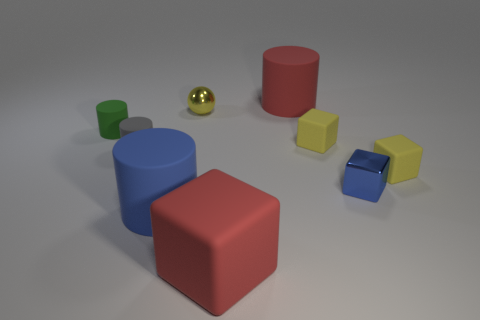Add 1 tiny matte cylinders. How many objects exist? 10 Subtract all blocks. How many objects are left? 5 Add 8 large cylinders. How many large cylinders exist? 10 Subtract 0 brown balls. How many objects are left? 9 Subtract all tiny yellow cubes. Subtract all big red rubber objects. How many objects are left? 5 Add 1 red things. How many red things are left? 3 